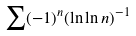<formula> <loc_0><loc_0><loc_500><loc_500>\sum ( - 1 ) ^ { n } ( \ln \ln n ) ^ { - 1 }</formula> 